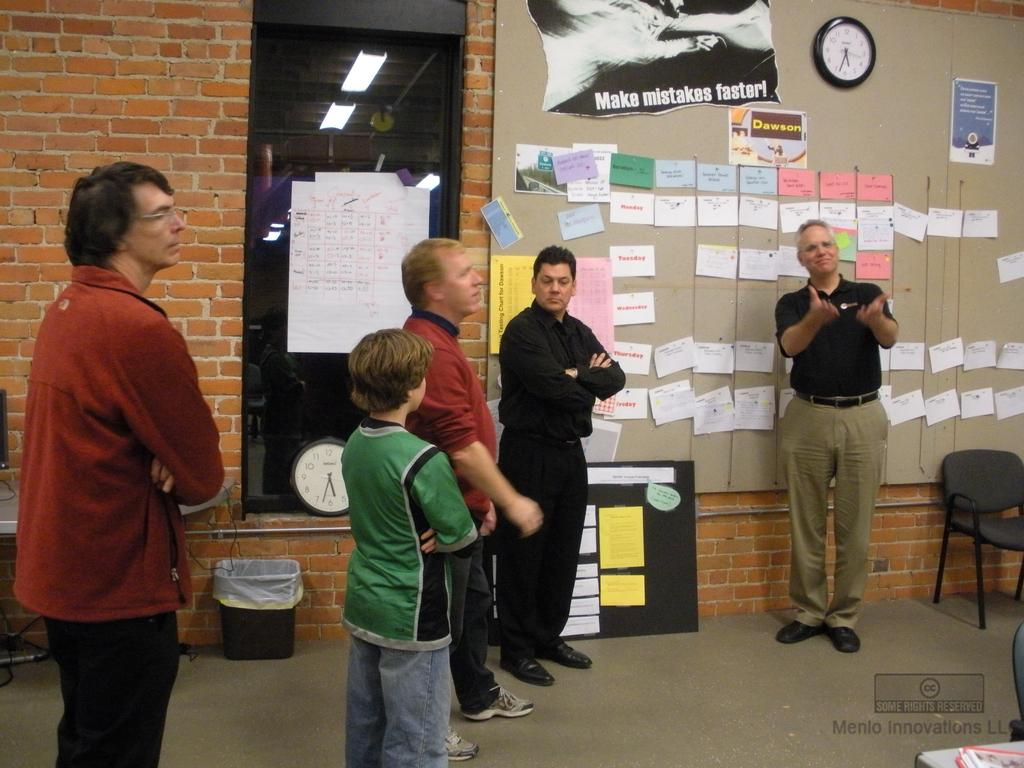How many individuals can be seen in the image? There are many people in the image. Can you identify any specific groups of people in the image? Four men and one boy are present in the image. What is one of the men doing in the image? One man is talking. What can be found attached to the wall in the image? There are papers attached to the wall. What time-keeping device is visible on the wall in the image? There is a clock on the wall. What type of station is being served for dinner in the image? There is no mention of a station or dinner in the image; it primarily features people and objects in a room. 